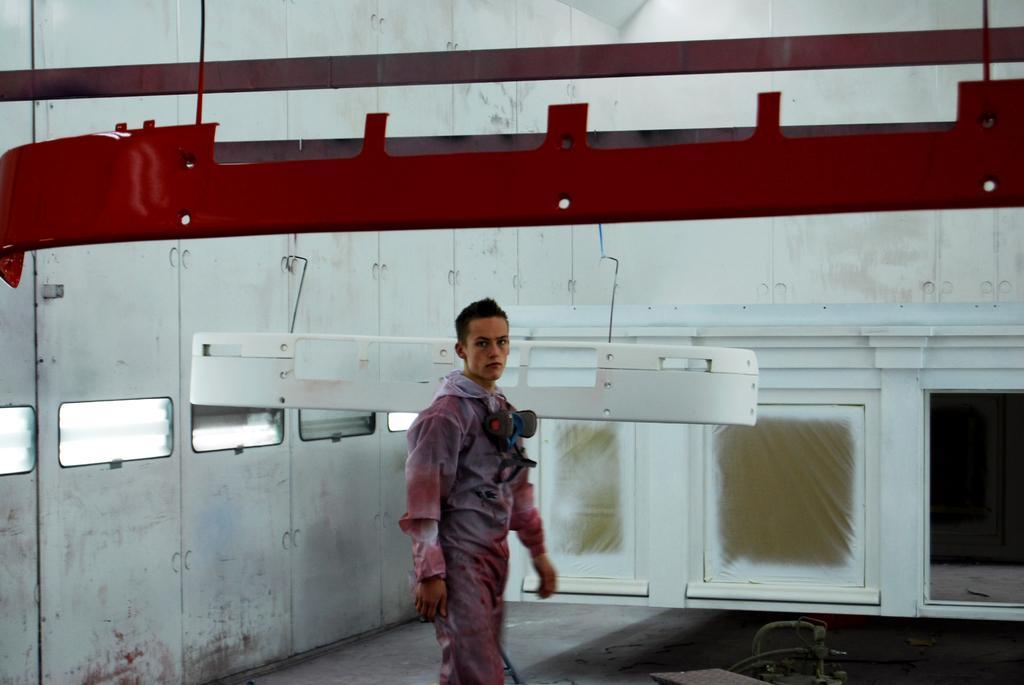Describe this image in one or two sentences. In this image there is a man walking on the floor. Behind him there is a wall. There are windows to the wall. There are metal rods hanging to the ceiling. 